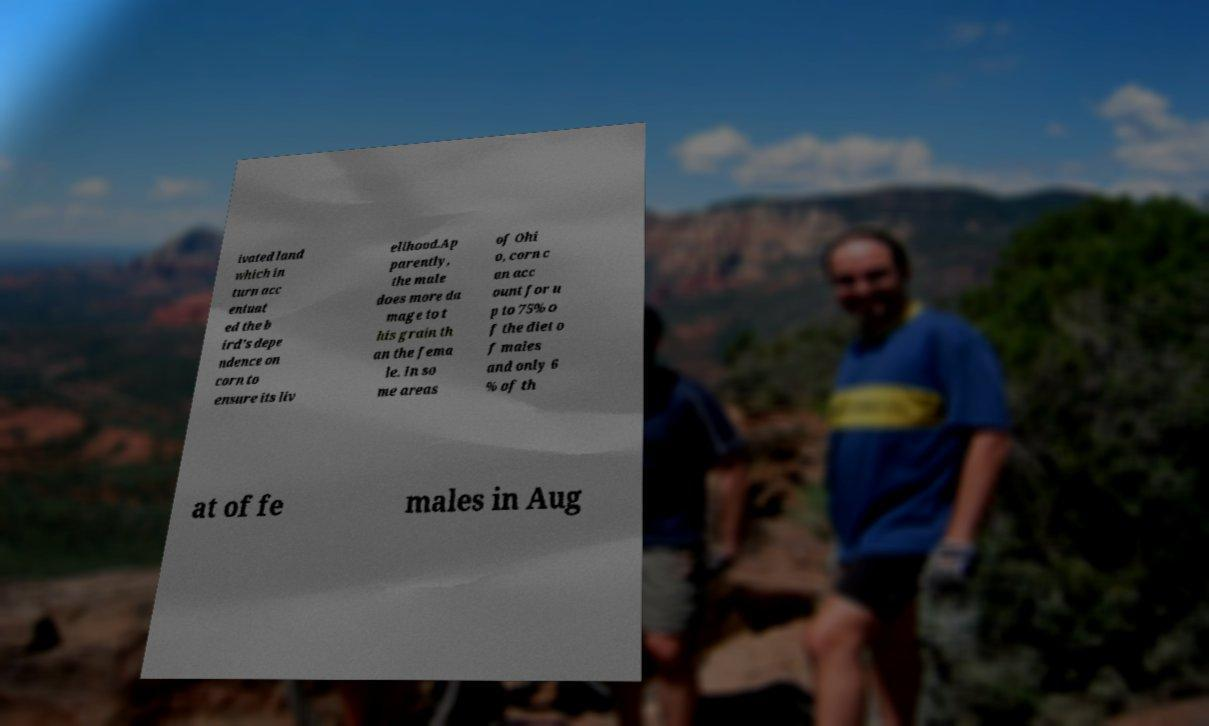Can you read and provide the text displayed in the image?This photo seems to have some interesting text. Can you extract and type it out for me? ivated land which in turn acc entuat ed the b ird's depe ndence on corn to ensure its liv elihood.Ap parently, the male does more da mage to t his grain th an the fema le. In so me areas of Ohi o, corn c an acc ount for u p to 75% o f the diet o f males and only 6 % of th at of fe males in Aug 